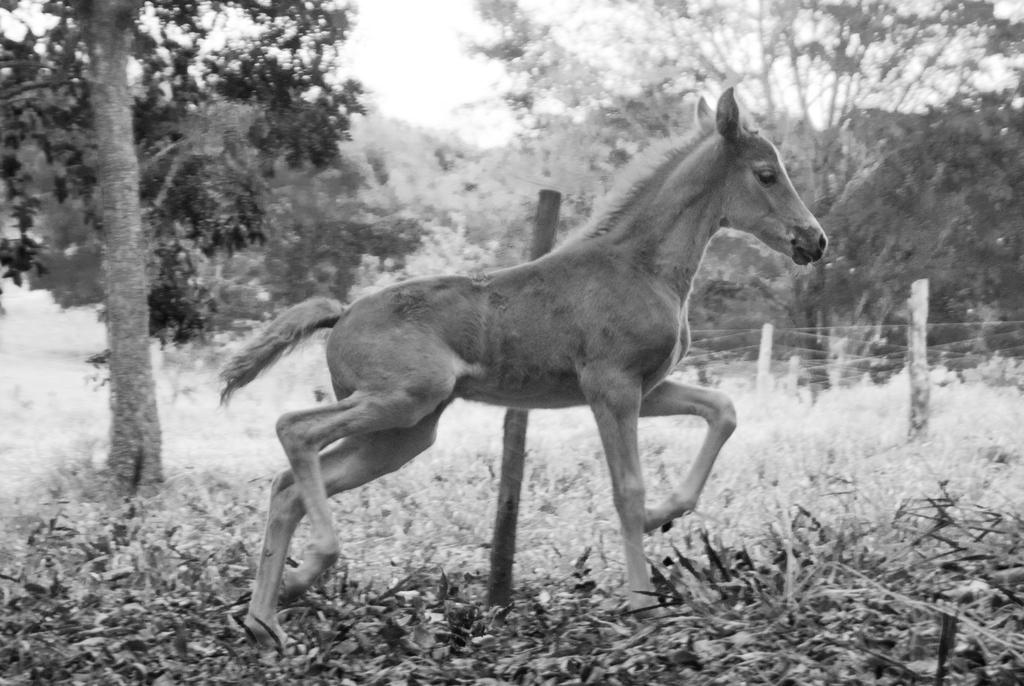What type of living creature is in the picture? There is an animal in the picture. What can be seen in the background of the picture? The sky, trees, a fence, and plants are visible in the background of the picture. What is the color scheme of the picture? The picture is black and white in color. What type of flower is being cared for by the animal in the picture? There is no flower present in the picture, and the animal is not shown caring for any object. 